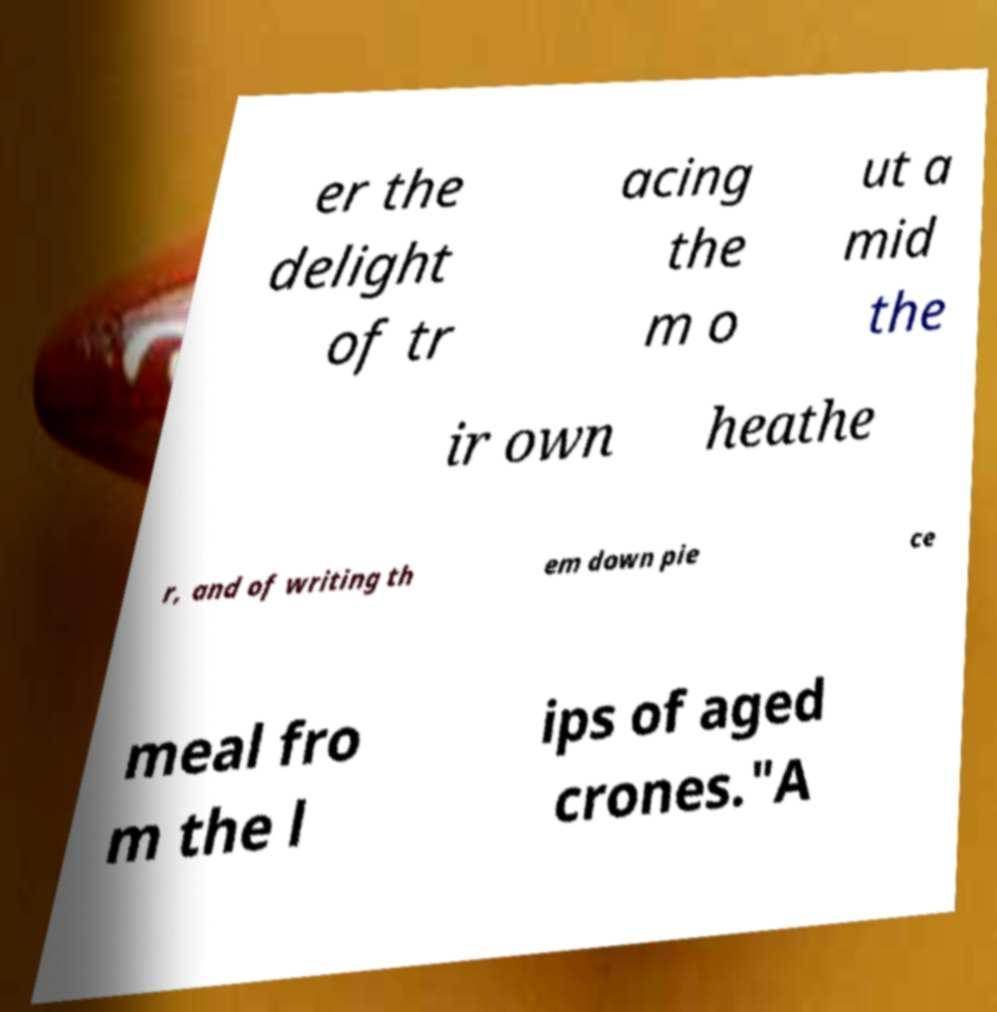What messages or text are displayed in this image? I need them in a readable, typed format. er the delight of tr acing the m o ut a mid the ir own heathe r, and of writing th em down pie ce meal fro m the l ips of aged crones."A 